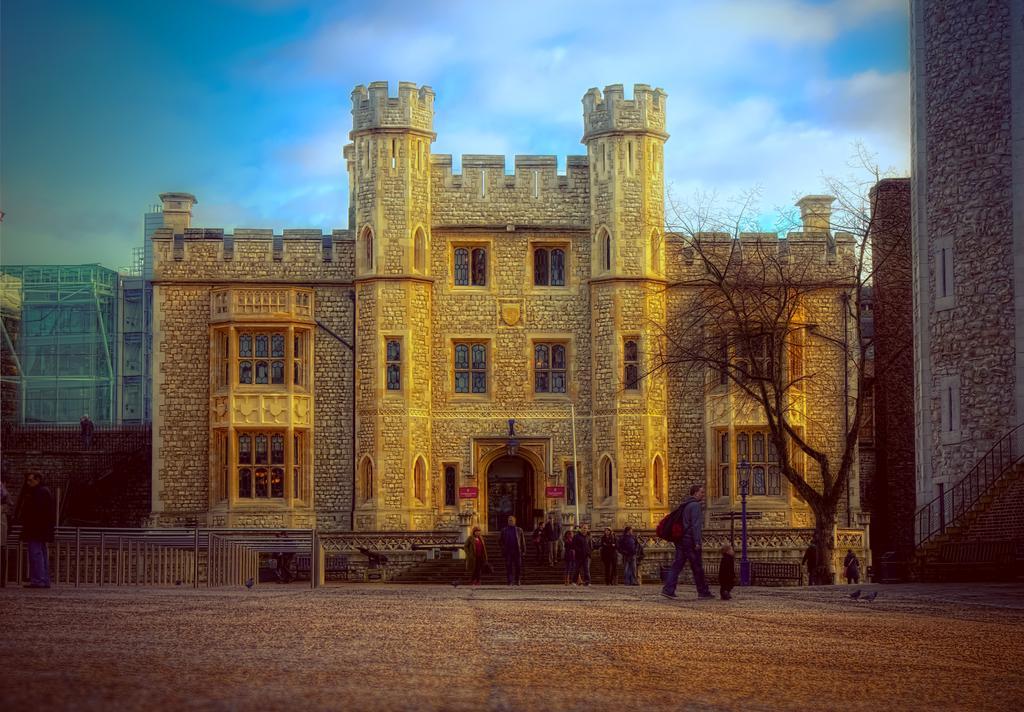Describe this image in one or two sentences. In this picture we can see few buildings, in front of the building we can find a tree, metal rods, few poles and group of people, and also we can see birds. 